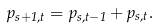<formula> <loc_0><loc_0><loc_500><loc_500>p _ { s + 1 , t } = p _ { s , t - 1 } + p _ { s , t } .</formula> 